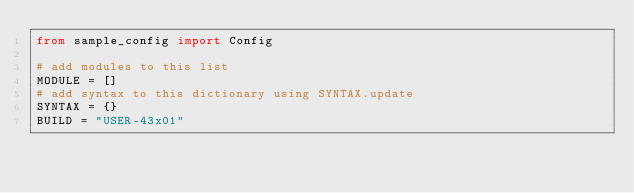<code> <loc_0><loc_0><loc_500><loc_500><_Python_>from sample_config import Config

# add modules to this list
MODULE = []
# add syntax to this dictionary using SYNTAX.update
SYNTAX = {}
BUILD = "USER-43x01"

</code> 